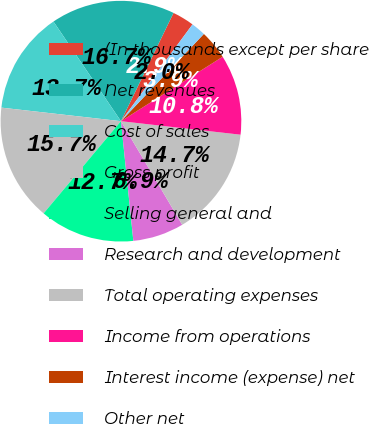Convert chart. <chart><loc_0><loc_0><loc_500><loc_500><pie_chart><fcel>(In thousands except per share<fcel>Net revenues<fcel>Cost of sales<fcel>Gross profit<fcel>Selling general and<fcel>Research and development<fcel>Total operating expenses<fcel>Income from operations<fcel>Interest income (expense) net<fcel>Other net<nl><fcel>2.94%<fcel>16.67%<fcel>13.73%<fcel>15.69%<fcel>12.75%<fcel>6.86%<fcel>14.71%<fcel>10.78%<fcel>3.92%<fcel>1.96%<nl></chart> 